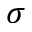<formula> <loc_0><loc_0><loc_500><loc_500>\sigma</formula> 